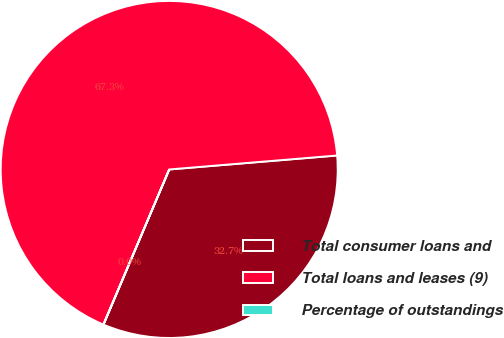Convert chart. <chart><loc_0><loc_0><loc_500><loc_500><pie_chart><fcel>Total consumer loans and<fcel>Total loans and leases (9)<fcel>Percentage of outstandings<nl><fcel>32.7%<fcel>67.29%<fcel>0.01%<nl></chart> 